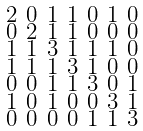<formula> <loc_0><loc_0><loc_500><loc_500>\begin{smallmatrix} 2 & 0 & 1 & 1 & 0 & 1 & 0 \\ 0 & 2 & 1 & 1 & 0 & 0 & 0 \\ 1 & 1 & 3 & 1 & 1 & 1 & 0 \\ 1 & 1 & 1 & 3 & 1 & 0 & 0 \\ 0 & 0 & 1 & 1 & 3 & 0 & 1 \\ 1 & 0 & 1 & 0 & 0 & 3 & 1 \\ 0 & 0 & 0 & 0 & 1 & 1 & 3 \end{smallmatrix}</formula> 